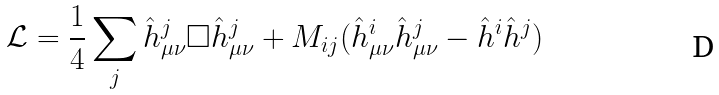Convert formula to latex. <formula><loc_0><loc_0><loc_500><loc_500>\mathcal { L } = \frac { 1 } { 4 } \sum _ { j } \hat { h } _ { \mu \nu } ^ { j } \Box \hat { h } _ { \mu \nu } ^ { j } + M _ { i j } ( \hat { h } ^ { i } _ { \mu \nu } \hat { h } ^ { j } _ { \mu \nu } - \hat { h } ^ { i } \hat { h } ^ { j } )</formula> 